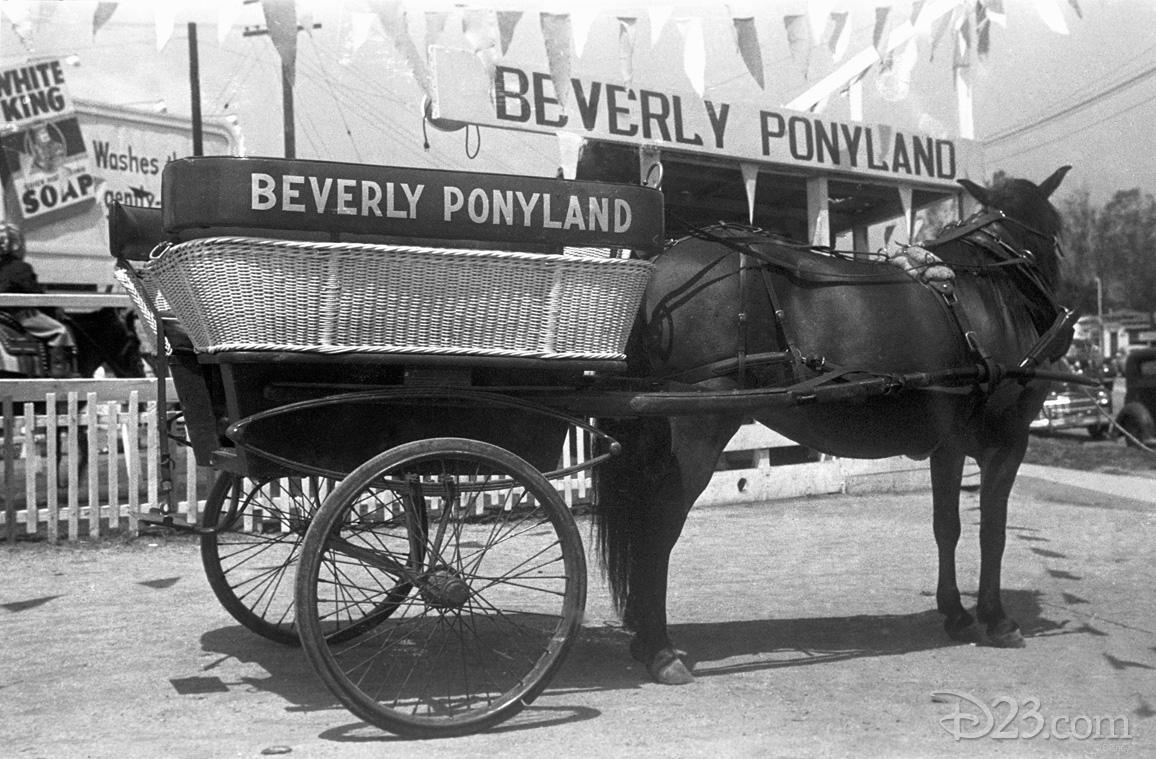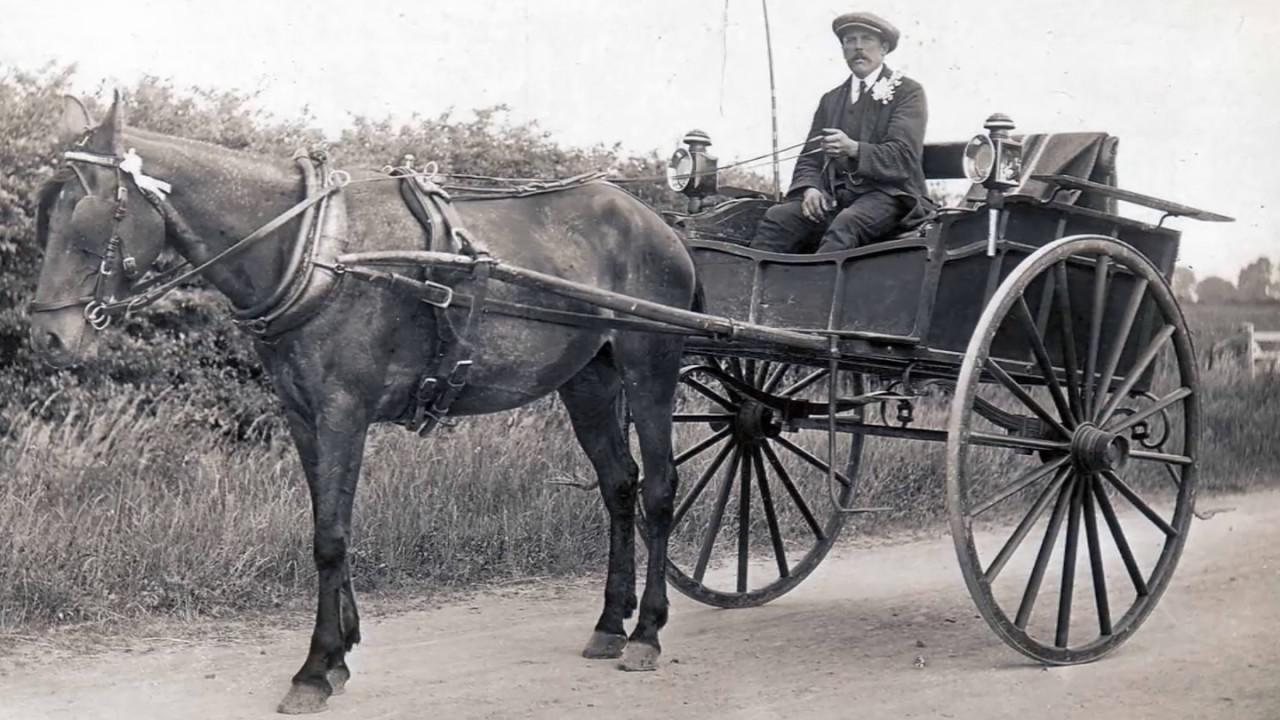The first image is the image on the left, the second image is the image on the right. Analyze the images presented: Is the assertion "The left image shows a two-wheeled wagon with no passengers." valid? Answer yes or no. Yes. The first image is the image on the left, the second image is the image on the right. Given the left and right images, does the statement "Two horses are pulling a single cart in the image on the right." hold true? Answer yes or no. No. 